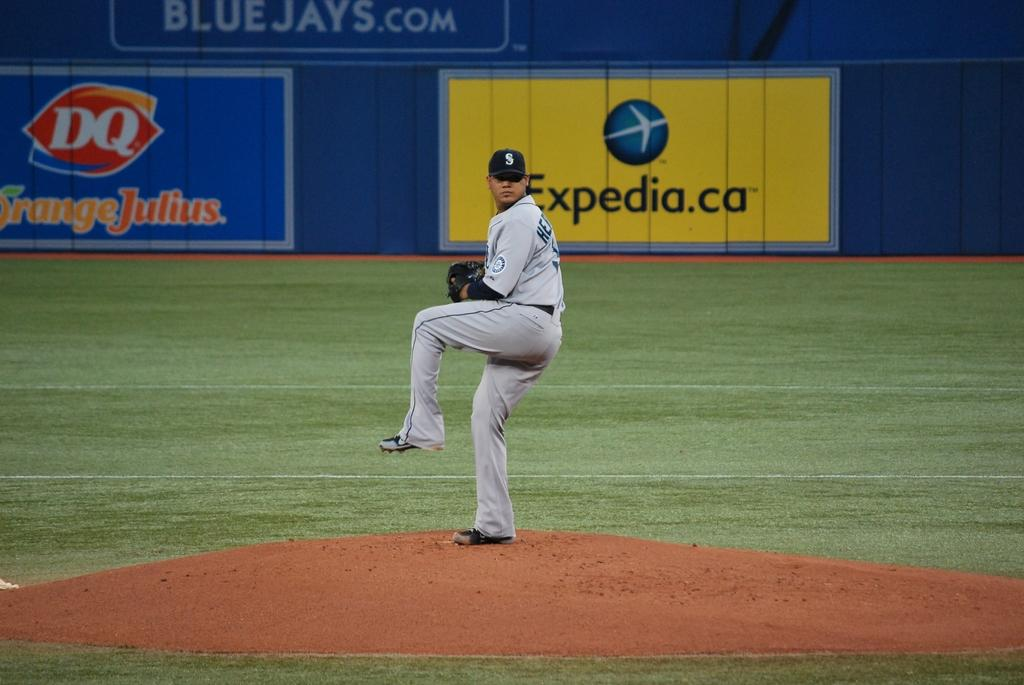<image>
Render a clear and concise summary of the photo. Pro baseball pitcher getting to throw a pitch from the mound with Expedia.ca and DQ sponsered sign boards in background. 